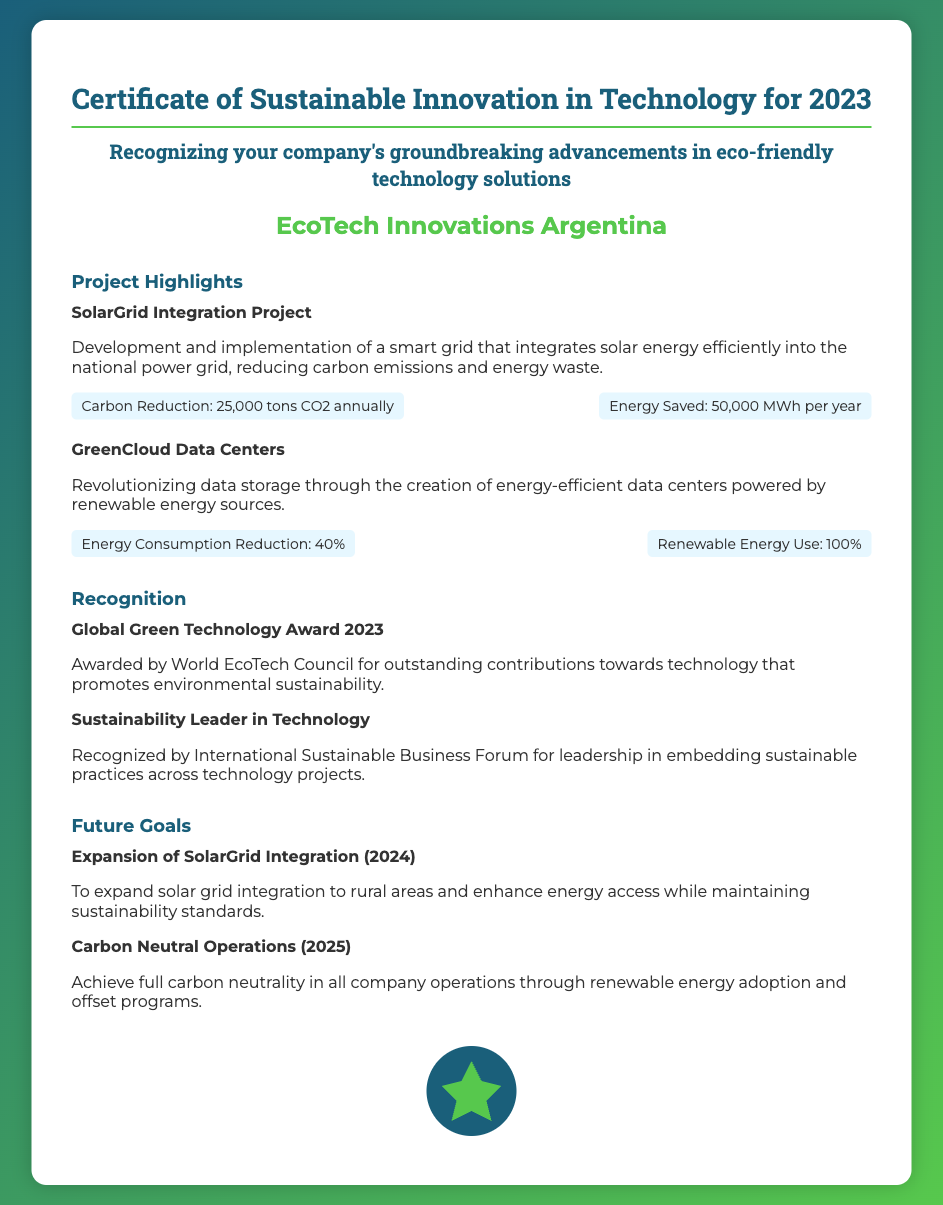What is the title of the certificate? The title of the certificate is the main heading in the document, which states the purpose of the certificate.
Answer: Certificate of Sustainable Innovation in Technology for 2023 Who is recognized in the certificate? The certificate recognizes the company specified under the company name section.
Answer: EcoTech Innovations Argentina What is the first project highlighted? The first project is the one listed at the beginning of the Project Highlights section, which describes its initiative.
Answer: SolarGrid Integration Project What is the carbon reduction achieved by the SolarGrid Integration Project? The specific metric given for carbon reduction is stated in the metrics section of the project details.
Answer: 25,000 tons CO2 annually What is one of the future goals for 2025? The future goals section lists aspirations for the company; the specific goal is noted directly.
Answer: Carbon Neutral Operations Which award did the company receive in 2023? The recognition section lists awards received, where the name of the award is provided.
Answer: Global Green Technology Award 2023 What is the percentage reduction in energy consumption for the GreenCloud Data Centers? The percentage is stated in the metrics section of the project details describing their achievement.
Answer: 40% What type of energy sources powers the GreenCloud Data Centers? The type of energy used is specified in the metrics section, highlighting sustainability efforts.
Answer: Renewable Energy Sources What was recognized by the International Sustainable Business Forum? This information is specified in the recognition section, stating the honor received by the company.
Answer: Leadership in embedding sustainable practices across technology projects 